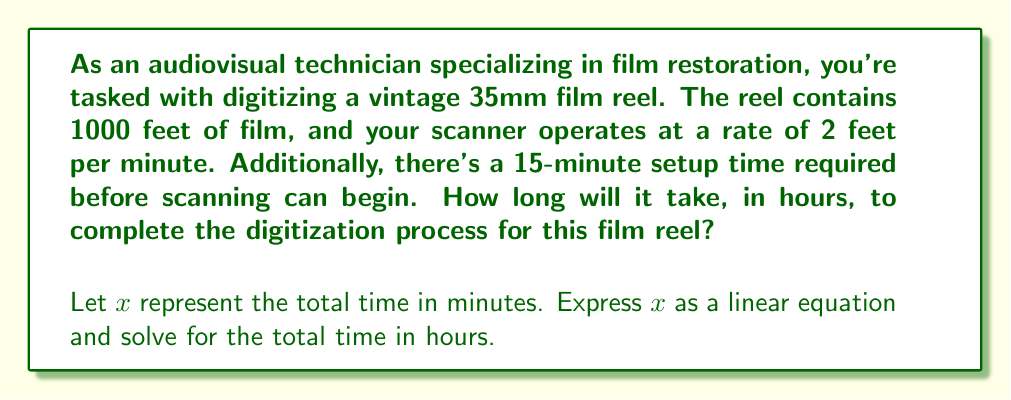Teach me how to tackle this problem. To solve this problem, we'll follow these steps:

1. Identify the given information:
   - Film length: 1000 feet
   - Scanning rate: 2 feet per minute
   - Setup time: 15 minutes

2. Set up the linear equation:
   Let $x$ be the total time in minutes.
   $$x = \text{setup time} + \text{scanning time}$$

3. Calculate the scanning time:
   Scanning time = Film length ÷ Scanning rate
   $$\text{Scanning time} = \frac{1000 \text{ feet}}{2 \text{ feet/minute}} = 500 \text{ minutes}$$

4. Substitute the values into the equation:
   $$x = 15 + 500 = 515 \text{ minutes}$$

5. Convert minutes to hours:
   $$\text{Time in hours} = \frac{515 \text{ minutes}}{60 \text{ minutes/hour}} = 8.5833... \text{ hours}$$

6. Round to two decimal places:
   8.58 hours
Answer: 8.58 hours 